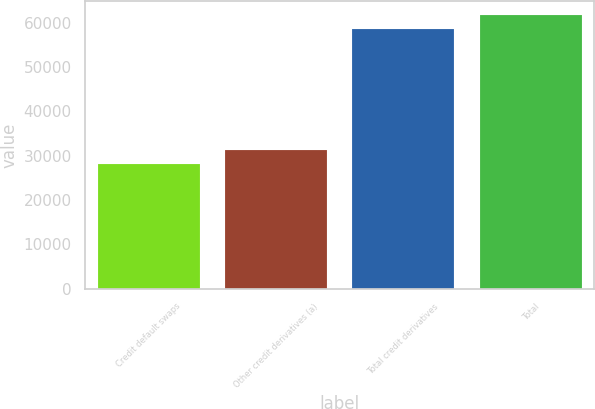<chart> <loc_0><loc_0><loc_500><loc_500><bar_chart><fcel>Credit default swaps<fcel>Other credit derivatives (a)<fcel>Total credit derivatives<fcel>Total<nl><fcel>28064<fcel>31284.1<fcel>58537<fcel>61757.1<nl></chart> 